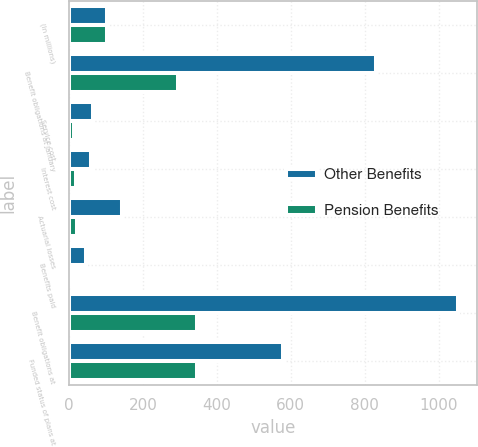Convert chart. <chart><loc_0><loc_0><loc_500><loc_500><stacked_bar_chart><ecel><fcel>(In millions)<fcel>Benefit obligations at January<fcel>Service cost<fcel>Interest cost<fcel>Actuarial losses<fcel>Benefits paid<fcel>Benefit obligations at<fcel>Funded status of plans at<nl><fcel>Other Benefits<fcel>104<fcel>831<fcel>64<fcel>59<fcel>144<fcel>47<fcel>1051<fcel>578<nl><fcel>Pension Benefits<fcel>104<fcel>295<fcel>15<fcel>19<fcel>21<fcel>4<fcel>346<fcel>346<nl></chart> 